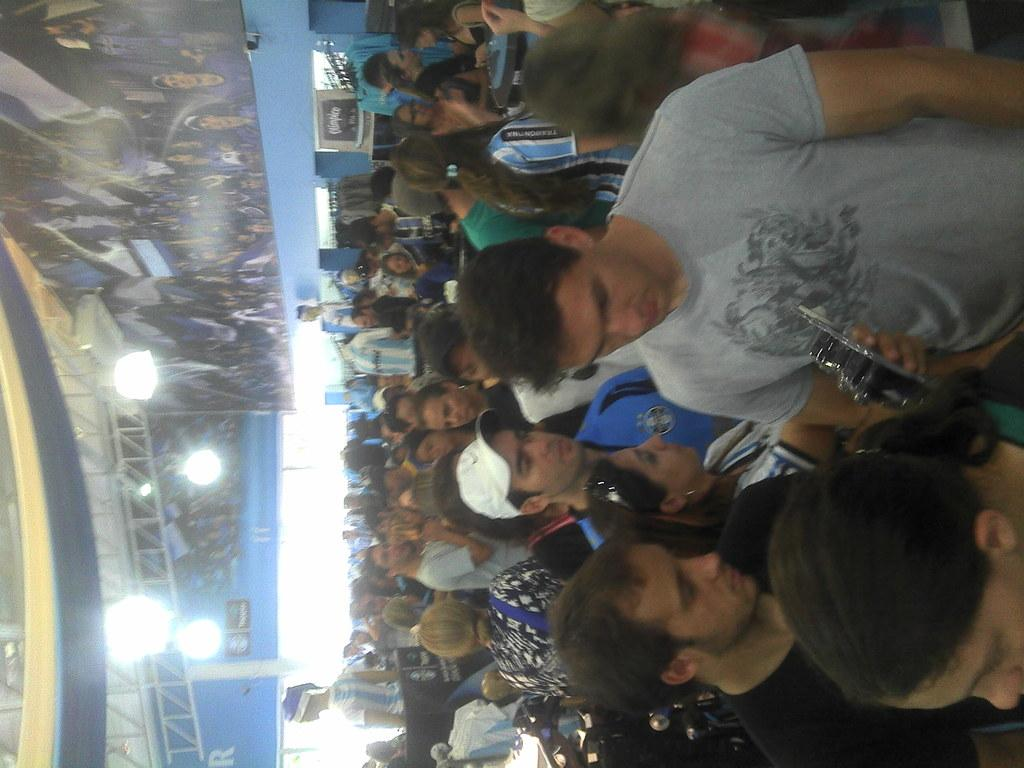What is happening in the image? There is a group of people standing in the image. Can you describe the person holding an object? A person is holding an object in the image. What can be seen on the left side of the image? There are pillars, banners, lights, and rods on the left side of the image. What type of sign is present in the image? There is no sign present in the image. What role does the government play in the image? The image does not depict any government involvement or activity. Can you describe the bun being held by the person in the image? There is no bun present in the image; the person is holding an unspecified object. 